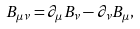<formula> <loc_0><loc_0><loc_500><loc_500>B _ { \mu \nu } = \partial _ { \mu } B _ { \nu } - \partial _ { \nu } B _ { \mu } ,</formula> 